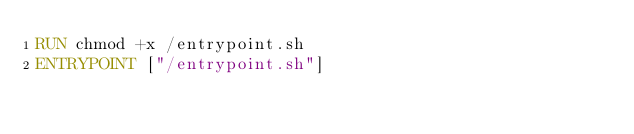Convert code to text. <code><loc_0><loc_0><loc_500><loc_500><_Dockerfile_>RUN chmod +x /entrypoint.sh
ENTRYPOINT ["/entrypoint.sh"]
</code> 